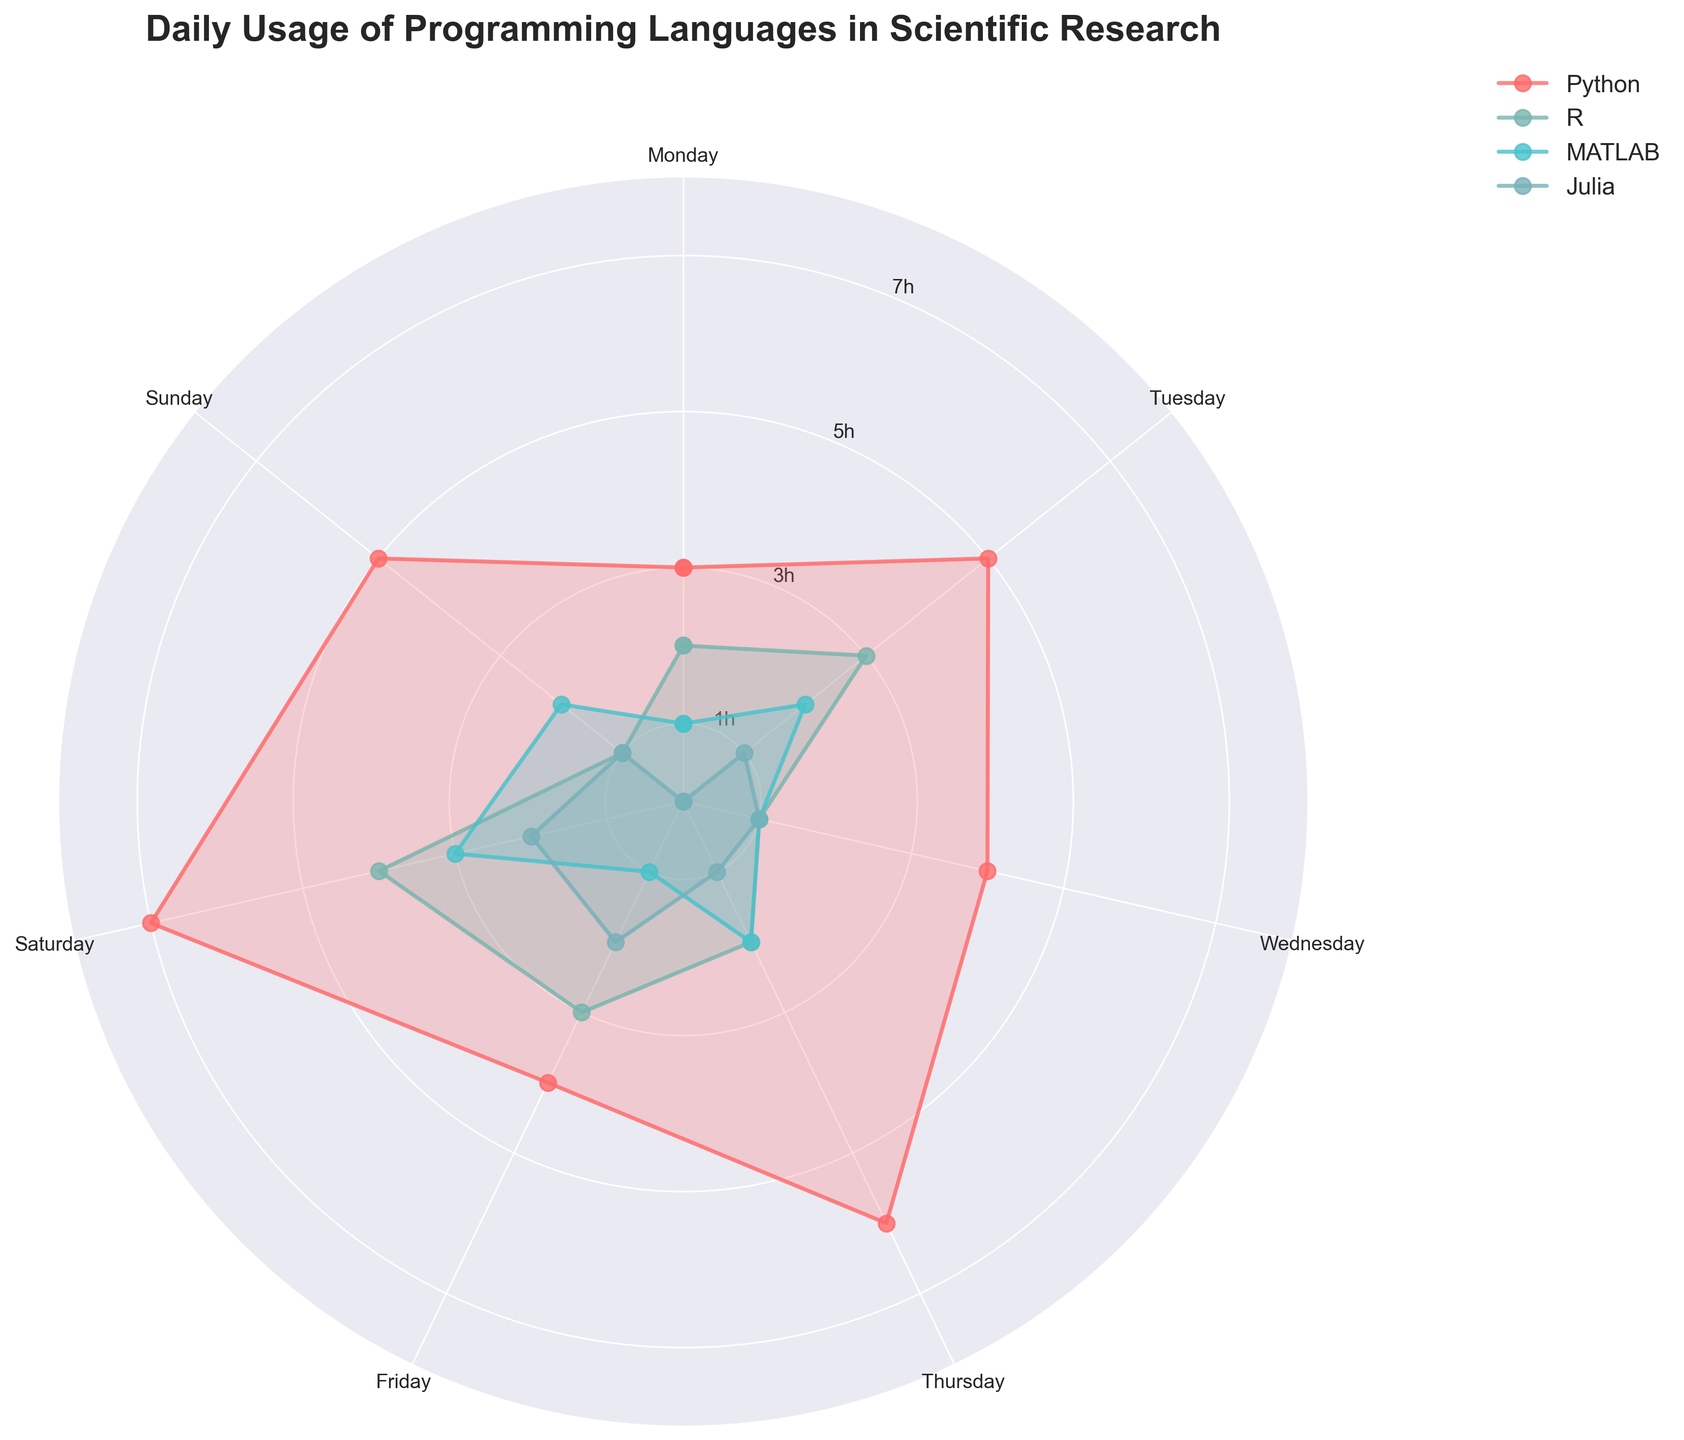What is the title of the figure? The title is usually displayed prominently at the top of the chart. In this figure, it reads "Daily Usage of Programming Languages in Scientific Research"
Answer: Daily Usage of Programming Languages in Scientific Research Which day shows the highest usage of Python? We observe the plot for Python (often indicated by the labels and legend), look for the highest point (most extended radial line) and note the corresponding day. The highest usage appears on Saturday.
Answer: Saturday What is the average usage hours for Python over the week? To find the average, sum the total usage hours for Python from all days (3+5+4+6+4+7+5 = 34) and then divide by the number of days (7). The average usage is 34/7
Answer: 4.86 hours Which language has the least overall usage throughout the week? Inspect each language's filled areas and lines to determine the overall usage. Julia has the smallest filled area and shorter lines, indicating the least usage.
Answer: Julia How many hours is R used on Thursday? Identify the segment for R on the polar plot, look at Thursday's direction, note how extended the line is, which is 2 hours.
Answer: 2 hours Compare the usage of Python and MATLAB on Tuesday. Which one is higher? By observing the plot, notice the respective lines for Tuesday. Python shows a higher spike compared to MATLAB on Tuesday.
Answer: Python On which day is MATLAB used the most? Identify the segments for MATLAB and compare the lengths or extent of lines. Saturday has the longest line for MATLAB.
Answer: Saturday What’s the total usage of R and Julia on Sunday? Sum up the usage hours for both languages on Sunday. R has 1 hour, and Julia has 1 hour on Sunday. So, the total is 1 + 1.
Answer: 2 hours Compare the usage pattern between R and MATLAB over the week. Which one is more consistent? Examine the fluctuations and variations in the hours plotted. MATLAB's usage shows less variance (mostly between 1-3 hours), indicating more consistency compared to R which fluctuates more notably.
Answer: MATLAB Which language shows the most significant increase in usage from Monday to Saturday? Measure the change in usage hours from Monday to Saturday for each language. Python increases from 3 to 7 hours, a 4-hour rise, which is the largest increase among all languages.
Answer: Python 